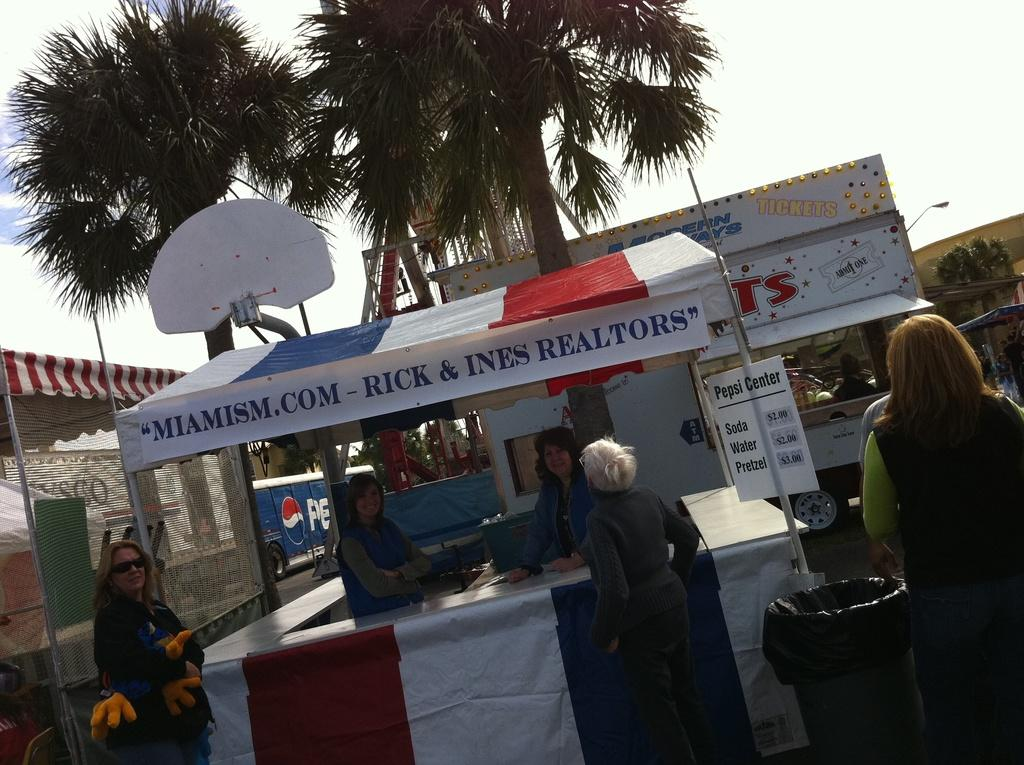How many people are in the group visible in the image? There is a group of people standing in the image, but the exact number cannot be determined from the provided facts. What object is used for waste disposal in the image? There is a dustbin in the image. What type of vertical structures can be seen in the image? There are poles in the image. What type of printed materials are present in the image? There are posters in the image. What type of transportation is visible in the image? There are vehicles in the image. What type of vegetation is present in the image? There are trees in the image. What is visible in the background of the image? The sky is visible in the background of the image. Can you see any feathers falling from the sky in the image? There is no mention of feathers or anything falling from the sky in the provided facts, so we cannot determine if they are present in the image. What type of emotion is the group of people feeling in the image? The provided facts do not mention the emotions of the people in the image, so we cannot determine their feelings. 